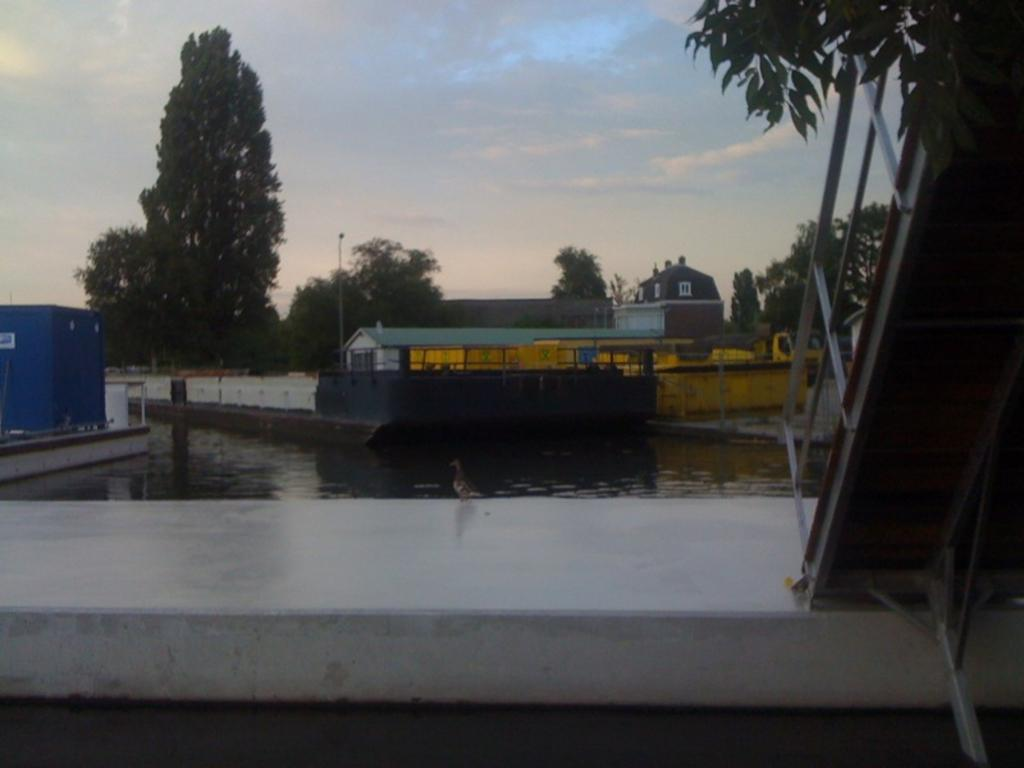What type of structures can be seen in the image? There are buildings in the image. What other objects are present in the image? There are poles, trees, windows, water, stairs, and the sky visible in the image. Can you describe the natural elements in the image? There are trees and water visible in the image. What architectural feature can be seen in the image? There are stairs in the image. Are there any dinosaurs visible in the image? No, there are no dinosaurs present in the image. Can you tell me what type of quill the dad is using in the image? There is no dad or quill present in the image. 